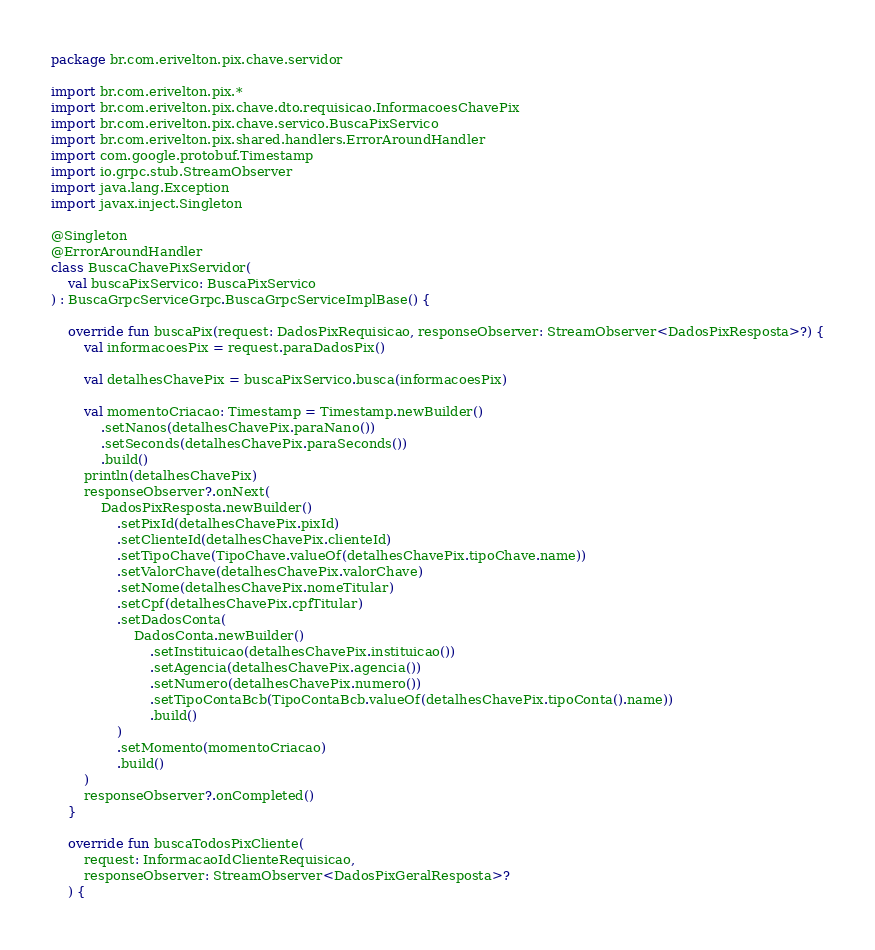<code> <loc_0><loc_0><loc_500><loc_500><_Kotlin_>package br.com.erivelton.pix.chave.servidor

import br.com.erivelton.pix.*
import br.com.erivelton.pix.chave.dto.requisicao.InformacoesChavePix
import br.com.erivelton.pix.chave.servico.BuscaPixServico
import br.com.erivelton.pix.shared.handlers.ErrorAroundHandler
import com.google.protobuf.Timestamp
import io.grpc.stub.StreamObserver
import java.lang.Exception
import javax.inject.Singleton

@Singleton
@ErrorAroundHandler
class BuscaChavePixServidor(
    val buscaPixServico: BuscaPixServico
) : BuscaGrpcServiceGrpc.BuscaGrpcServiceImplBase() {

    override fun buscaPix(request: DadosPixRequisicao, responseObserver: StreamObserver<DadosPixResposta>?) {
        val informacoesPix = request.paraDadosPix()

        val detalhesChavePix = buscaPixServico.busca(informacoesPix)

        val momentoCriacao: Timestamp = Timestamp.newBuilder()
            .setNanos(detalhesChavePix.paraNano())
            .setSeconds(detalhesChavePix.paraSeconds())
            .build()
        println(detalhesChavePix)
        responseObserver?.onNext(
            DadosPixResposta.newBuilder()
                .setPixId(detalhesChavePix.pixId)
                .setClienteId(detalhesChavePix.clienteId)
                .setTipoChave(TipoChave.valueOf(detalhesChavePix.tipoChave.name))
                .setValorChave(detalhesChavePix.valorChave)
                .setNome(detalhesChavePix.nomeTitular)
                .setCpf(detalhesChavePix.cpfTitular)
                .setDadosConta(
                    DadosConta.newBuilder()
                        .setInstituicao(detalhesChavePix.instituicao())
                        .setAgencia(detalhesChavePix.agencia())
                        .setNumero(detalhesChavePix.numero())
                        .setTipoContaBcb(TipoContaBcb.valueOf(detalhesChavePix.tipoConta().name))
                        .build()
                )
                .setMomento(momentoCriacao)
                .build()
        )
        responseObserver?.onCompleted()
    }

    override fun buscaTodosPixCliente(
        request: InformacaoIdClienteRequisicao,
        responseObserver: StreamObserver<DadosPixGeralResposta>?
    ) {</code> 